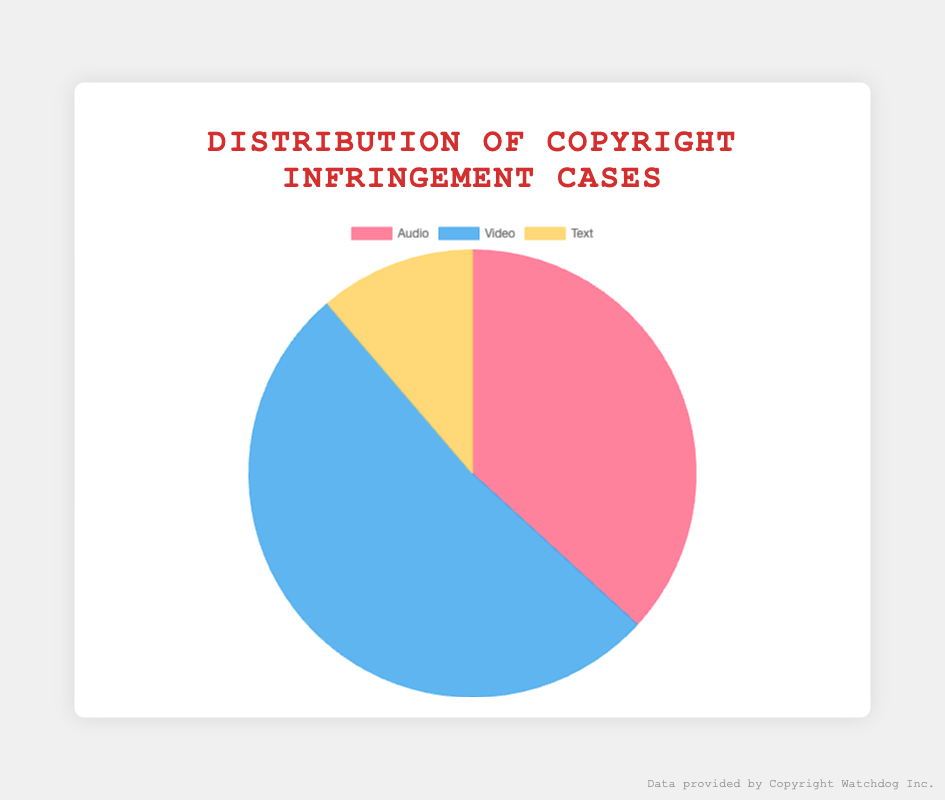Which type of content has the highest number of infringement cases overall? The pie chart shows three segments for Audio, Video, and Text. By observing the sizes, Video has the largest portion.
Answer: Video How many infringement cases are recorded for Text? Adding the infringement cases for Text (Medium: 40, Wattpad: 55, Amazon Kindle: 35) gives 40 + 55 + 35 = 130 cases.
Answer: 130 Which type of content has the smallest fraction in the pie chart? The pie chart visually indicates that Text has the smallest segment compared to Audio and Video.
Answer: Text What is the difference in infringement cases between Audio and Video? Audio's total is 200 + 150 + 75 = 425, Video's total is 300 + 220 + 80 = 600. The difference is 600 - 425 = 175.
Answer: 175 How many more infringement cases are there in Video compared to Text? Total cases in Video (300 + 220 + 80) = 600; in Text (40 + 55 + 35) = 130. So, 600 - 130 = 470.
Answer: 470 Which category has the middle-sized segment in the pie chart? By comparing the pie chart segments, Audio appears between Video (largest) and Text (smallest).
Answer: Audio What percentage of the total infringement cases does Audio account for? Total cases: Audio (425) + Video (600) + Text (130) = 1,155. Percentage for Audio = (425 / 1,155) * 100 ≈ 36.8%.
Answer: 36.8% Are there more infringement cases in Audio or Text? From the pie chart, the Audio segment is visibly larger than the Text segment. Thus, Audio has more cases.
Answer: Audio What is the sum of infringement cases from the largest and smallest categories? Video: 600 cases, Text: 130 cases. Sum = 600 + 130 = 730.
Answer: 730 If one more infringement case were added to Text, what would the new total be for Text? Current total for Text is 130. Adding one more case, the new total is 130 + 1 = 131.
Answer: 131 